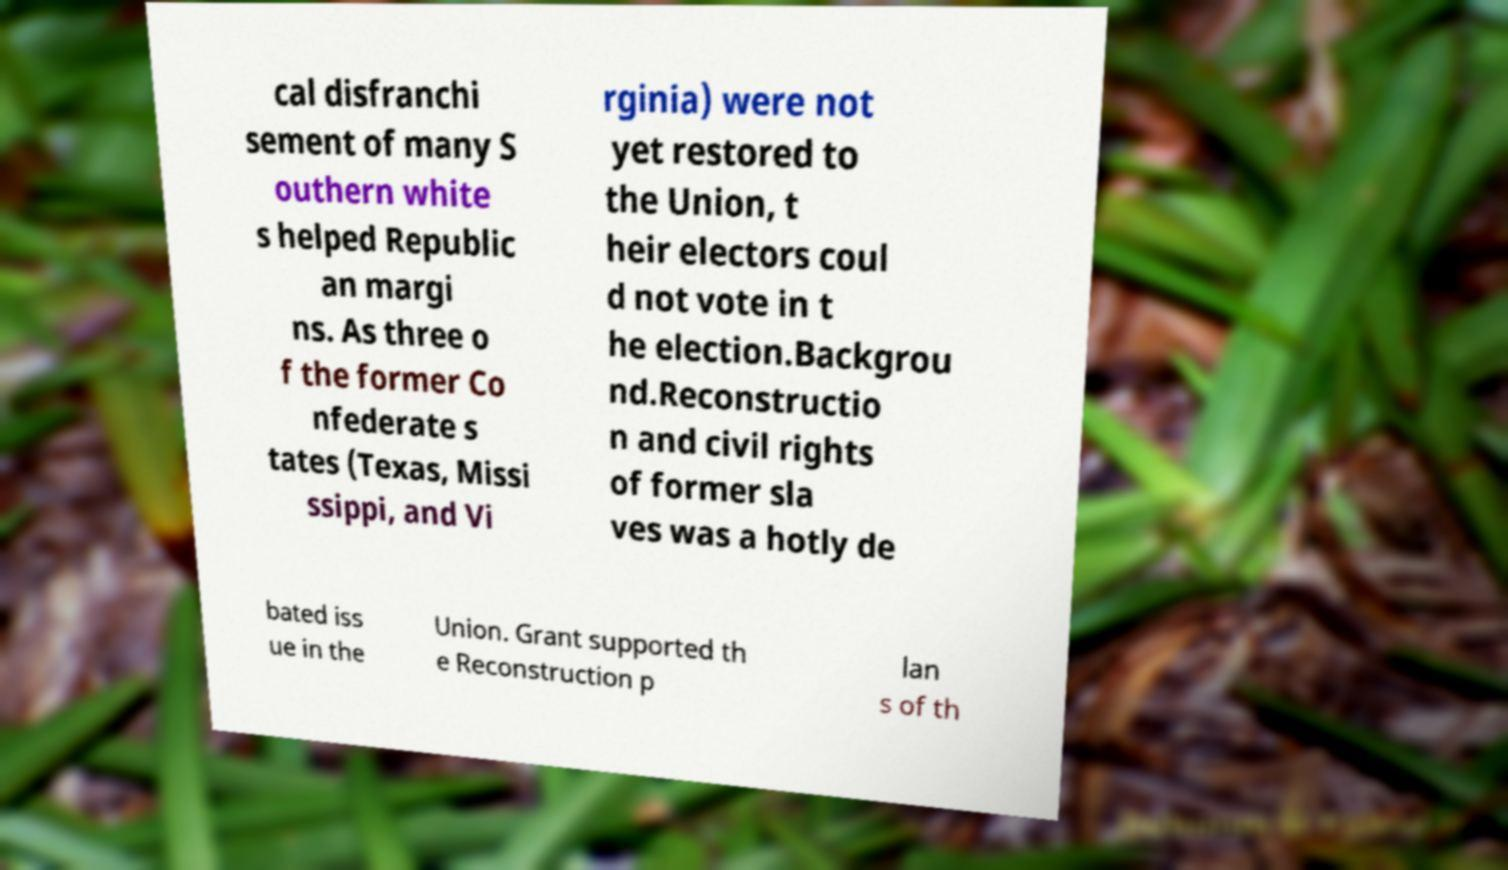I need the written content from this picture converted into text. Can you do that? cal disfranchi sement of many S outhern white s helped Republic an margi ns. As three o f the former Co nfederate s tates (Texas, Missi ssippi, and Vi rginia) were not yet restored to the Union, t heir electors coul d not vote in t he election.Backgrou nd.Reconstructio n and civil rights of former sla ves was a hotly de bated iss ue in the Union. Grant supported th e Reconstruction p lan s of th 